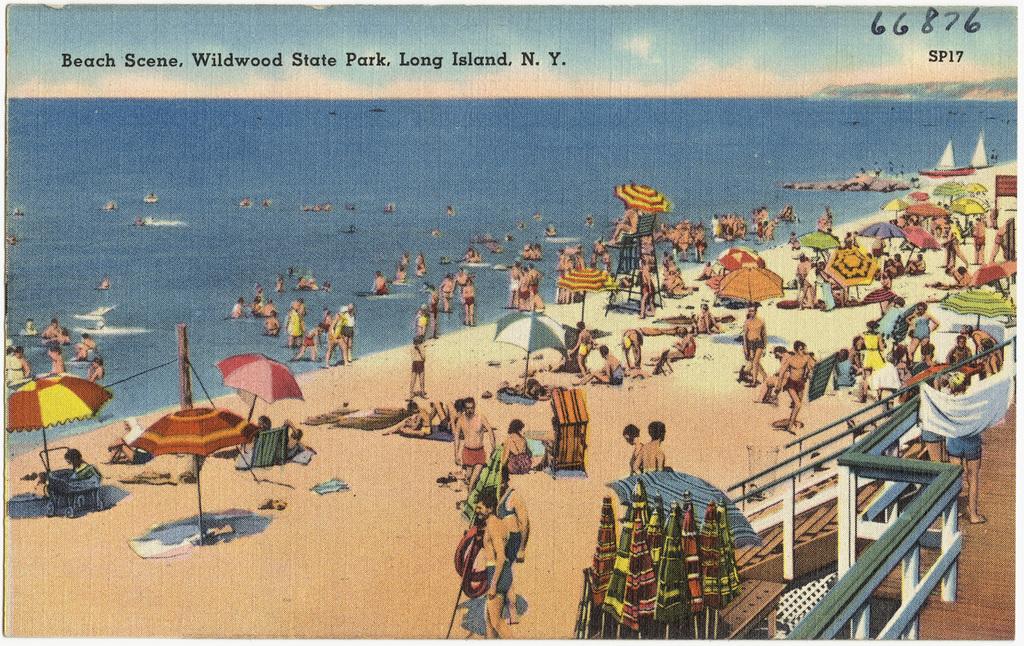What is the name of the state park?
Provide a succinct answer. Wildwood. Is this an old postcard?
Provide a short and direct response. Yes. 